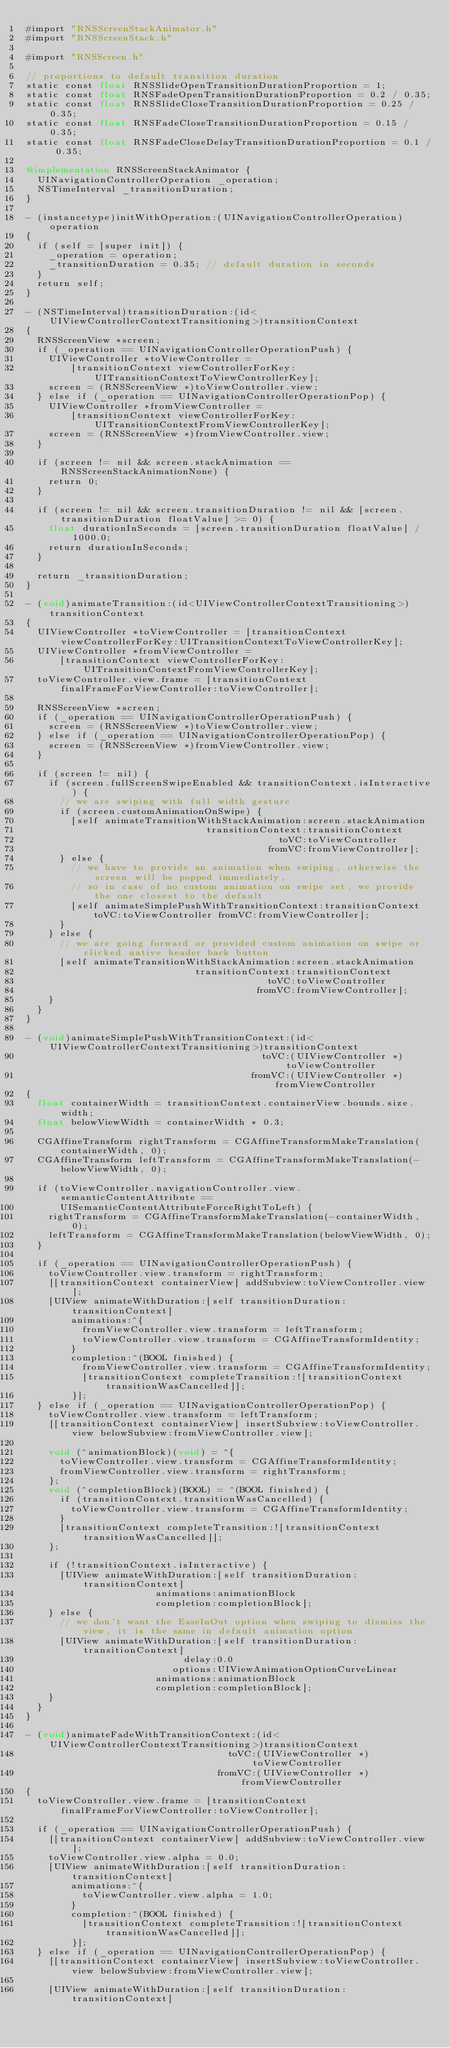Convert code to text. <code><loc_0><loc_0><loc_500><loc_500><_ObjectiveC_>#import "RNSScreenStackAnimator.h"
#import "RNSScreenStack.h"

#import "RNSScreen.h"

// proportions to default transition duration
static const float RNSSlideOpenTransitionDurationProportion = 1;
static const float RNSFadeOpenTransitionDurationProportion = 0.2 / 0.35;
static const float RNSSlideCloseTransitionDurationProportion = 0.25 / 0.35;
static const float RNSFadeCloseTransitionDurationProportion = 0.15 / 0.35;
static const float RNSFadeCloseDelayTransitionDurationProportion = 0.1 / 0.35;

@implementation RNSScreenStackAnimator {
  UINavigationControllerOperation _operation;
  NSTimeInterval _transitionDuration;
}

- (instancetype)initWithOperation:(UINavigationControllerOperation)operation
{
  if (self = [super init]) {
    _operation = operation;
    _transitionDuration = 0.35; // default duration in seconds
  }
  return self;
}

- (NSTimeInterval)transitionDuration:(id<UIViewControllerContextTransitioning>)transitionContext
{
  RNSScreenView *screen;
  if (_operation == UINavigationControllerOperationPush) {
    UIViewController *toViewController =
        [transitionContext viewControllerForKey:UITransitionContextToViewControllerKey];
    screen = (RNSScreenView *)toViewController.view;
  } else if (_operation == UINavigationControllerOperationPop) {
    UIViewController *fromViewController =
        [transitionContext viewControllerForKey:UITransitionContextFromViewControllerKey];
    screen = (RNSScreenView *)fromViewController.view;
  }

  if (screen != nil && screen.stackAnimation == RNSScreenStackAnimationNone) {
    return 0;
  }

  if (screen != nil && screen.transitionDuration != nil && [screen.transitionDuration floatValue] >= 0) {
    float durationInSeconds = [screen.transitionDuration floatValue] / 1000.0;
    return durationInSeconds;
  }

  return _transitionDuration;
}

- (void)animateTransition:(id<UIViewControllerContextTransitioning>)transitionContext
{
  UIViewController *toViewController = [transitionContext viewControllerForKey:UITransitionContextToViewControllerKey];
  UIViewController *fromViewController =
      [transitionContext viewControllerForKey:UITransitionContextFromViewControllerKey];
  toViewController.view.frame = [transitionContext finalFrameForViewController:toViewController];

  RNSScreenView *screen;
  if (_operation == UINavigationControllerOperationPush) {
    screen = (RNSScreenView *)toViewController.view;
  } else if (_operation == UINavigationControllerOperationPop) {
    screen = (RNSScreenView *)fromViewController.view;
  }

  if (screen != nil) {
    if (screen.fullScreenSwipeEnabled && transitionContext.isInteractive) {
      // we are swiping with full width gesture
      if (screen.customAnimationOnSwipe) {
        [self animateTransitionWithStackAnimation:screen.stackAnimation
                                transitionContext:transitionContext
                                             toVC:toViewController
                                           fromVC:fromViewController];
      } else {
        // we have to provide an animation when swiping, otherwise the screen will be popped immediately,
        // so in case of no custom animation on swipe set, we provide the one closest to the default
        [self animateSimplePushWithTransitionContext:transitionContext toVC:toViewController fromVC:fromViewController];
      }
    } else {
      // we are going forward or provided custom animation on swipe or clicked native header back button
      [self animateTransitionWithStackAnimation:screen.stackAnimation
                              transitionContext:transitionContext
                                           toVC:toViewController
                                         fromVC:fromViewController];
    }
  }
}

- (void)animateSimplePushWithTransitionContext:(id<UIViewControllerContextTransitioning>)transitionContext
                                          toVC:(UIViewController *)toViewController
                                        fromVC:(UIViewController *)fromViewController
{
  float containerWidth = transitionContext.containerView.bounds.size.width;
  float belowViewWidth = containerWidth * 0.3;

  CGAffineTransform rightTransform = CGAffineTransformMakeTranslation(containerWidth, 0);
  CGAffineTransform leftTransform = CGAffineTransformMakeTranslation(-belowViewWidth, 0);

  if (toViewController.navigationController.view.semanticContentAttribute ==
      UISemanticContentAttributeForceRightToLeft) {
    rightTransform = CGAffineTransformMakeTranslation(-containerWidth, 0);
    leftTransform = CGAffineTransformMakeTranslation(belowViewWidth, 0);
  }

  if (_operation == UINavigationControllerOperationPush) {
    toViewController.view.transform = rightTransform;
    [[transitionContext containerView] addSubview:toViewController.view];
    [UIView animateWithDuration:[self transitionDuration:transitionContext]
        animations:^{
          fromViewController.view.transform = leftTransform;
          toViewController.view.transform = CGAffineTransformIdentity;
        }
        completion:^(BOOL finished) {
          fromViewController.view.transform = CGAffineTransformIdentity;
          [transitionContext completeTransition:![transitionContext transitionWasCancelled]];
        }];
  } else if (_operation == UINavigationControllerOperationPop) {
    toViewController.view.transform = leftTransform;
    [[transitionContext containerView] insertSubview:toViewController.view belowSubview:fromViewController.view];

    void (^animationBlock)(void) = ^{
      toViewController.view.transform = CGAffineTransformIdentity;
      fromViewController.view.transform = rightTransform;
    };
    void (^completionBlock)(BOOL) = ^(BOOL finished) {
      if (transitionContext.transitionWasCancelled) {
        toViewController.view.transform = CGAffineTransformIdentity;
      }
      [transitionContext completeTransition:![transitionContext transitionWasCancelled]];
    };

    if (!transitionContext.isInteractive) {
      [UIView animateWithDuration:[self transitionDuration:transitionContext]
                       animations:animationBlock
                       completion:completionBlock];
    } else {
      // we don't want the EaseInOut option when swiping to dismiss the view, it is the same in default animation option
      [UIView animateWithDuration:[self transitionDuration:transitionContext]
                            delay:0.0
                          options:UIViewAnimationOptionCurveLinear
                       animations:animationBlock
                       completion:completionBlock];
    }
  }
}

- (void)animateFadeWithTransitionContext:(id<UIViewControllerContextTransitioning>)transitionContext
                                    toVC:(UIViewController *)toViewController
                                  fromVC:(UIViewController *)fromViewController
{
  toViewController.view.frame = [transitionContext finalFrameForViewController:toViewController];

  if (_operation == UINavigationControllerOperationPush) {
    [[transitionContext containerView] addSubview:toViewController.view];
    toViewController.view.alpha = 0.0;
    [UIView animateWithDuration:[self transitionDuration:transitionContext]
        animations:^{
          toViewController.view.alpha = 1.0;
        }
        completion:^(BOOL finished) {
          [transitionContext completeTransition:![transitionContext transitionWasCancelled]];
        }];
  } else if (_operation == UINavigationControllerOperationPop) {
    [[transitionContext containerView] insertSubview:toViewController.view belowSubview:fromViewController.view];

    [UIView animateWithDuration:[self transitionDuration:transitionContext]</code> 